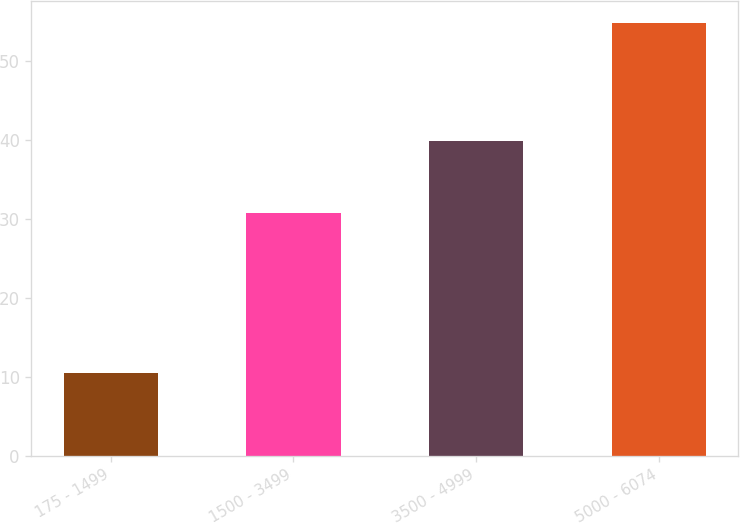Convert chart to OTSL. <chart><loc_0><loc_0><loc_500><loc_500><bar_chart><fcel>175 - 1499<fcel>1500 - 3499<fcel>3500 - 4999<fcel>5000 - 6074<nl><fcel>10.44<fcel>30.73<fcel>39.96<fcel>54.86<nl></chart> 